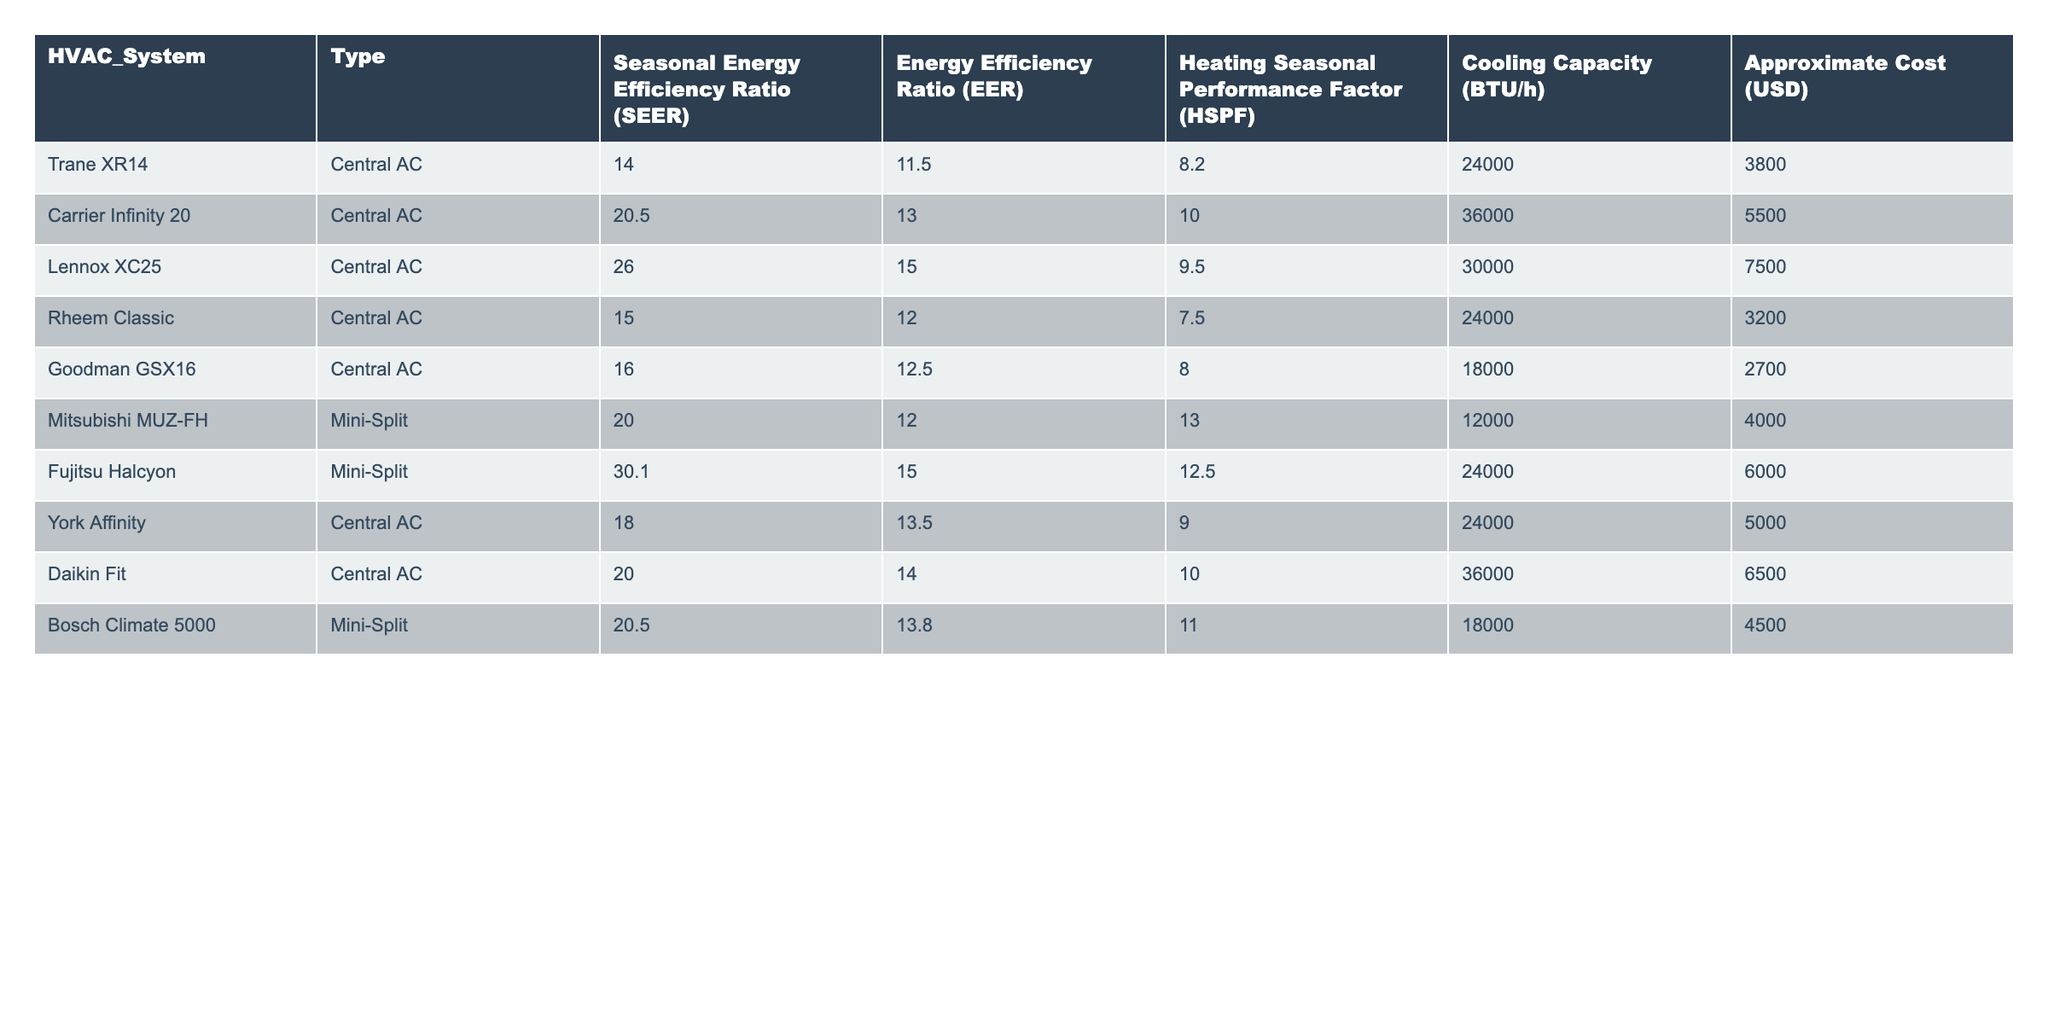What is the highest Seasonal Energy Efficiency Ratio (SEER) among the HVAC systems listed? Looking at the SEER values in the table, the highest value is 30.1, which corresponds to the Fujitsu Halcyon.
Answer: 30.1 Which HVAC system has the lowest approximate cost? Reviewing the cost values, the Goodman GSX16 has the lowest approximate cost of 2700 USD.
Answer: 2700 How many HVAC systems have a Heating Seasonal Performance Factor (HSPF) greater than 10? By examining the HSPF values, three systems (Mitsubishi MUZ-FH, Daikin Fit, and Fujitsu Halcyon) have an HSPF greater than 10.
Answer: 3 What is the average Cooling Capacity of the HVAC systems listed? Summing the Cooling Capacity values: (24000 + 36000 + 30000 + 24000 + 18000 + 12000 + 24000 + 36000 + 18000) gives 240000. Dividing by the number of systems (9) results in an average of 240000/9 = 26666.67.
Answer: 26666.67 Is there an HVAC system type that offers both central AC and mini-split options? Based on the table, the HVAC systems listed are either Central AC or Mini-Split, with no system being both types.
Answer: No What is the total cost of all HVAC systems combined? Adding the costs: 3800 + 5500 + 7500 + 3200 + 2700 + 4000 + 6000 + 6500 + 4500 equals 40500.
Answer: 40500 Which HVAC system has the highest Energy Efficiency Ratio (EER), and what is its value? Looking at the EER values, the Lennox XC25 has the highest EER at 15.0.
Answer: Lennox XC25, 15.0 How does the SEER of the Carrier Infinity 20 compare to that of the Goodman GSX16? The SEER of Carrier Infinity 20 is 20.5 while Goodman GSX16 is 16, showing that Carrier Infinity 20 is more efficient with a difference of 4.5.
Answer: 4.5 more Which type of HVAC system generally has higher average efficiency ratings, Central AC or Mini-Split? Calculating the average SEER for Central AC (14 + 20.5 + 26 + 15 + 16 + 18 + 20) = 16.64 and for Mini-Split (20 + 30.1 + 20.5) = 23.53 shows that Mini-Split generally has higher average efficiency ratings.
Answer: Mini-Split If the Fujitsu Halcyon were to be selected, how much would the cost differ from the Trane XR14? Fujitsu Halcyon costs 6000 USD and Trane XR14 costs 3800 USD; the difference is 6000 - 3800 = 2200 USD.
Answer: 2200 